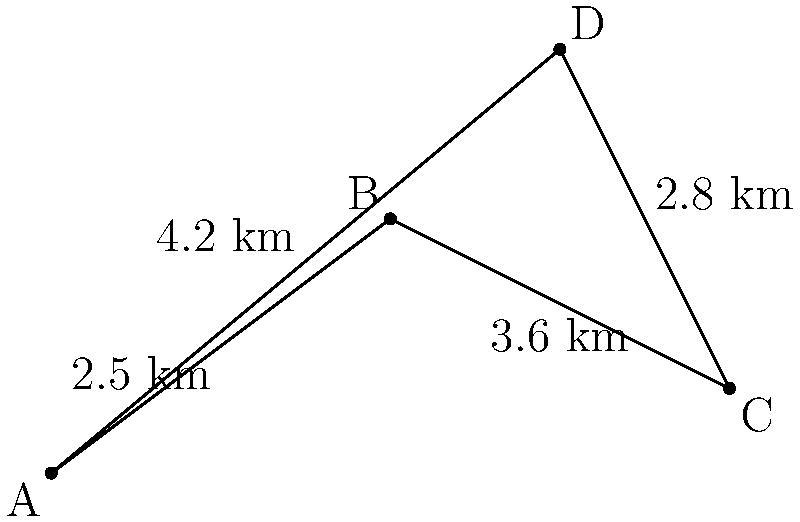A busy executive needs to visit four client locations in a city, represented by points A, B, C, and D on the map. The distances between adjacent points are shown. What is the shortest possible route that visits all four locations exactly once and returns to the starting point? Give your answer as a sequence of letters representing the order of visits. To find the shortest route, we need to consider all possible paths and calculate their total distances:

1. A-B-C-D-A: $2.5 + 3.6 + 2.8 + 4.2 = 13.1$ km
2. A-B-D-C-A: $2.5 + \sqrt{2^2 + 2^2} + 2.8 + 8 = 13.3 + \sqrt{8}$ km
3. A-C-B-D-A: $8 + 3.6 + \sqrt{2^2 + 2^2} + 4.2 = 15.8 + \sqrt{8}$ km
4. A-C-D-B-A: $8 + 2.8 + \sqrt{2^2 + 2^2} + 2.5 = 13.3 + \sqrt{8}$ km
5. A-D-B-C-A: $4.2 + \sqrt{2^2 + 2^2} + 3.6 + 8 = 15.8 + \sqrt{8}$ km
6. A-D-C-B-A: $4.2 + 2.8 + 3.6 + 2.5 = 13.1$ km

The shortest routes are A-B-C-D-A and A-D-C-B-A, both with a distance of 13.1 km. We can choose either of these routes.
Answer: ABCDA or ADCBA 